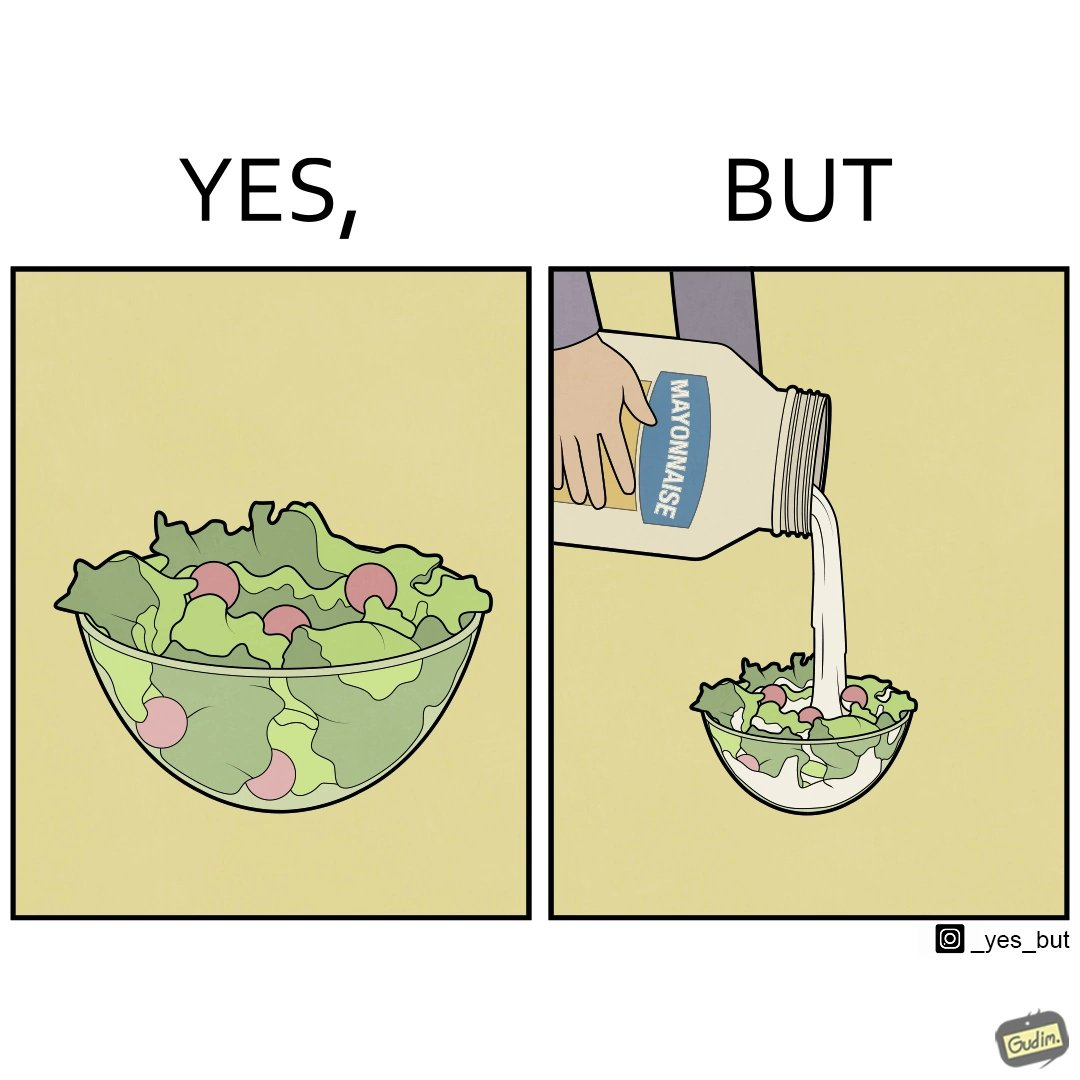What is shown in this image? The image is ironical, as salad in a bowl by itself is very healthy. However, when people have it with Mayonnaise sauce to improve the taste, it is not healthy anymore, and defeats the point of having nutrient-rich salad altogether. 